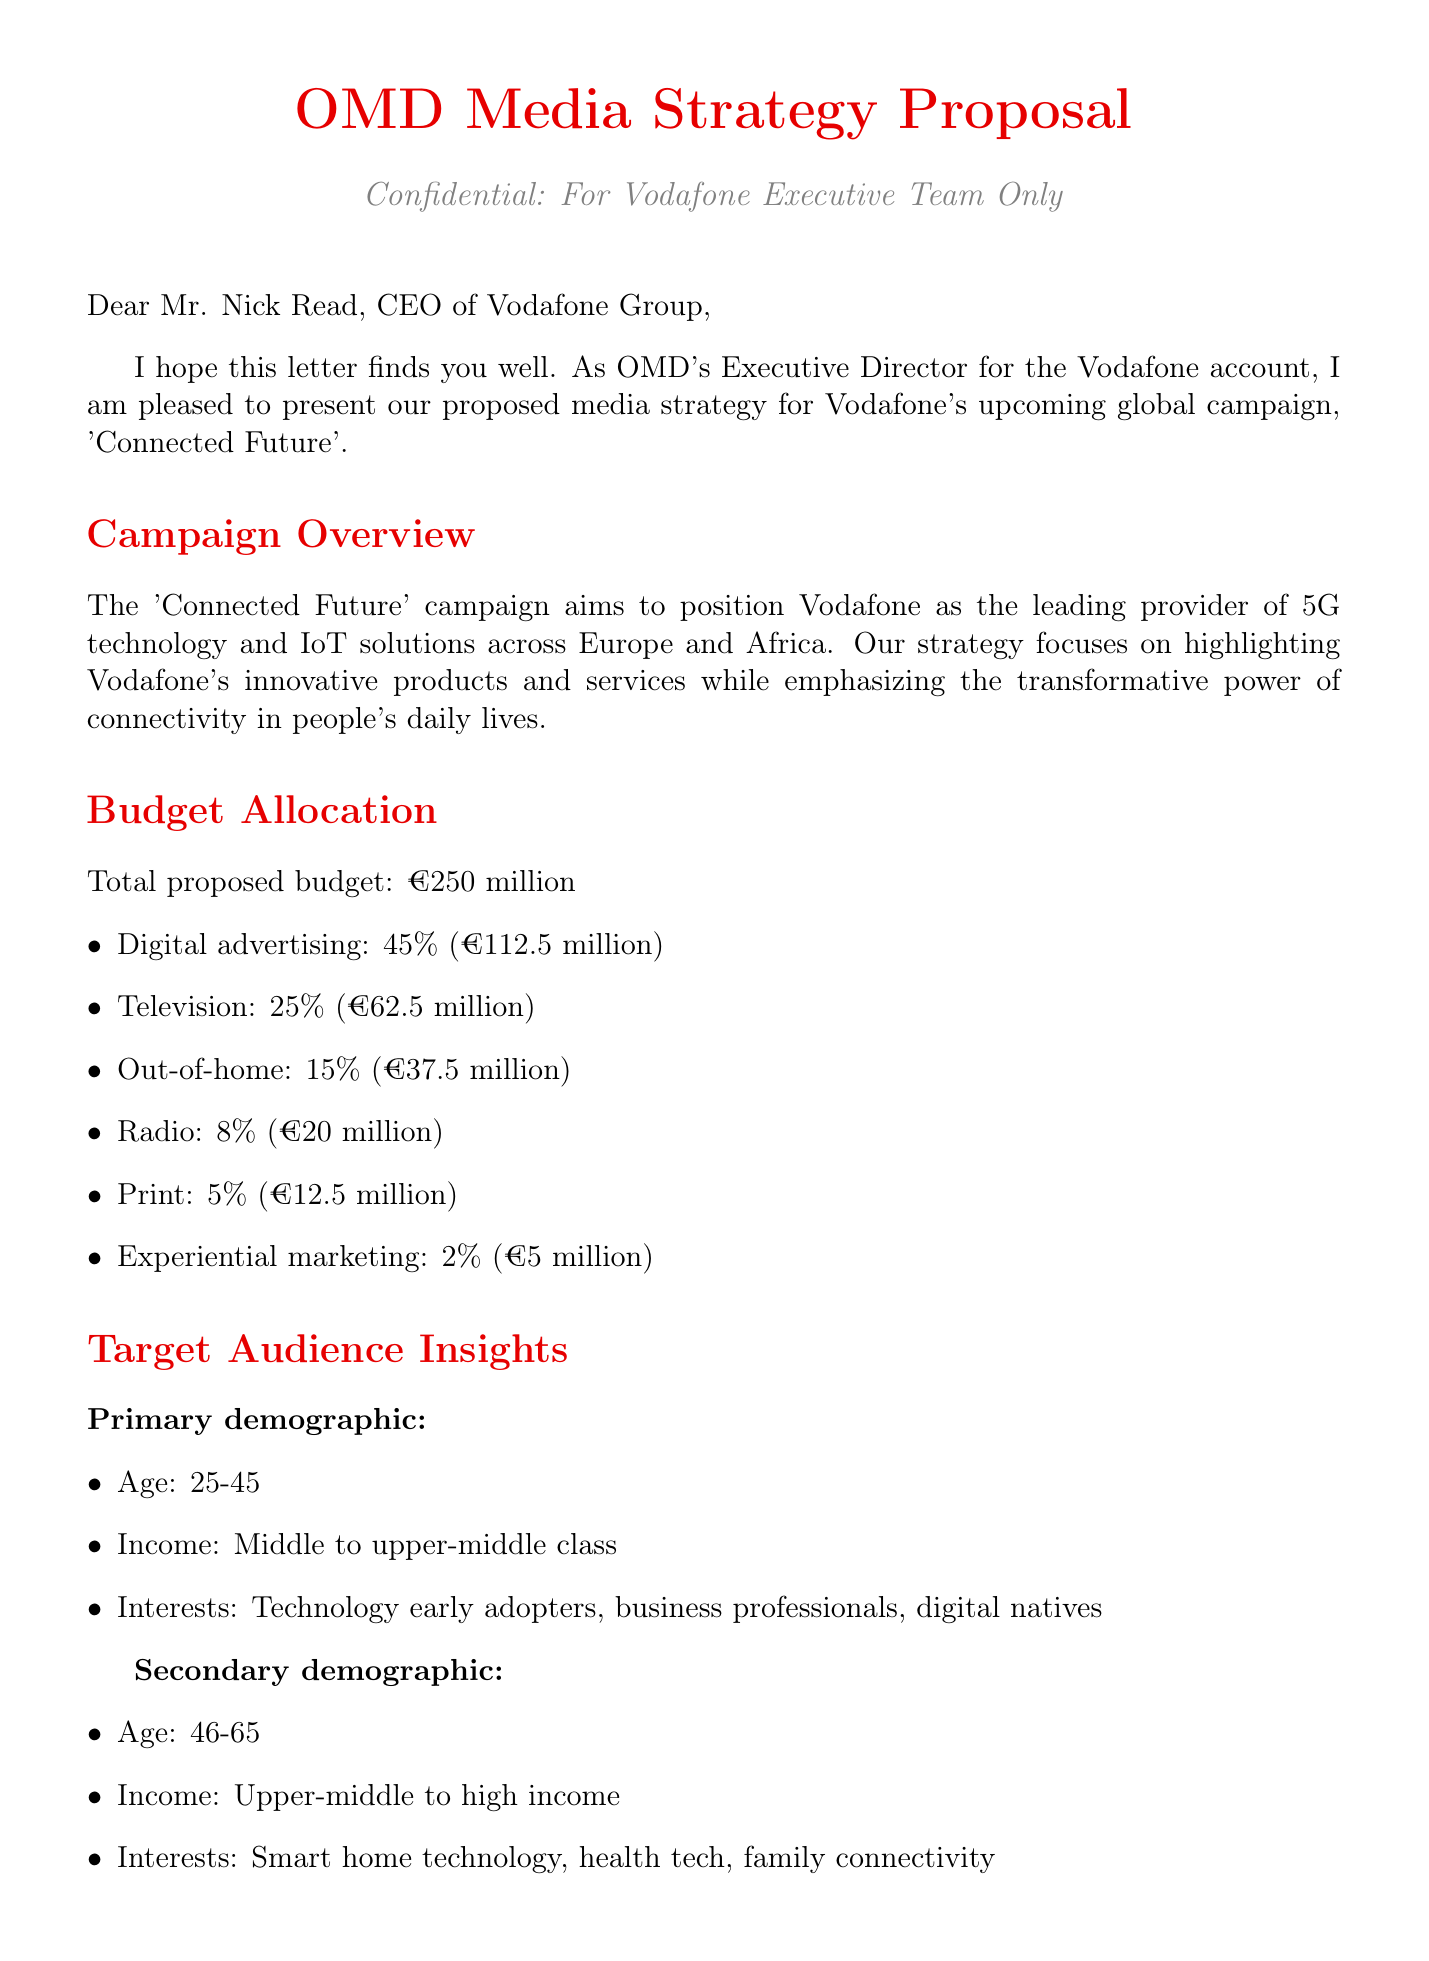What is the total proposed budget for the campaign? The total proposed budget is explicitly stated in the document under the Budget Allocation section.
Answer: €250 million What percentage of the budget is allocated to digital advertising? The percentage allocated to digital advertising is detailed in the Budget Allocation section.
Answer: 45% Who is the CEO of Vodafone Group mentioned in the letter? The letter begins with a greeting directed to the CEO, naming him.
Answer: Mr. Nick Read What is the primary demographic age range targeted by the campaign? The age range for the primary demographic is listed under Target Audience Insights.
Answer: 25-45 What is the expected lift in brand awareness? The expected lift in brand awareness is included in the Key Performance Indicators section.
Answer: 15% Which social media platforms are included in the digital media strategy? The document lists social media platforms in the Media Mix Strategy, specifying which are being utilized.
Answer: Facebook, Instagram, LinkedIn When is the campaign scheduled to launch? The launch date of the campaign is clearly stated in the Timeline section.
Answer: September 1, 2023 What type of partnership is recommended with Samsung? The type of partnership is identified in the Partnerships and Collaborations section of the document.
Answer: Joint 5G device promotions How long will the campaign run? The duration of the campaign is outlined in the Timeline section, specifying the length of time.
Answer: 6 months 